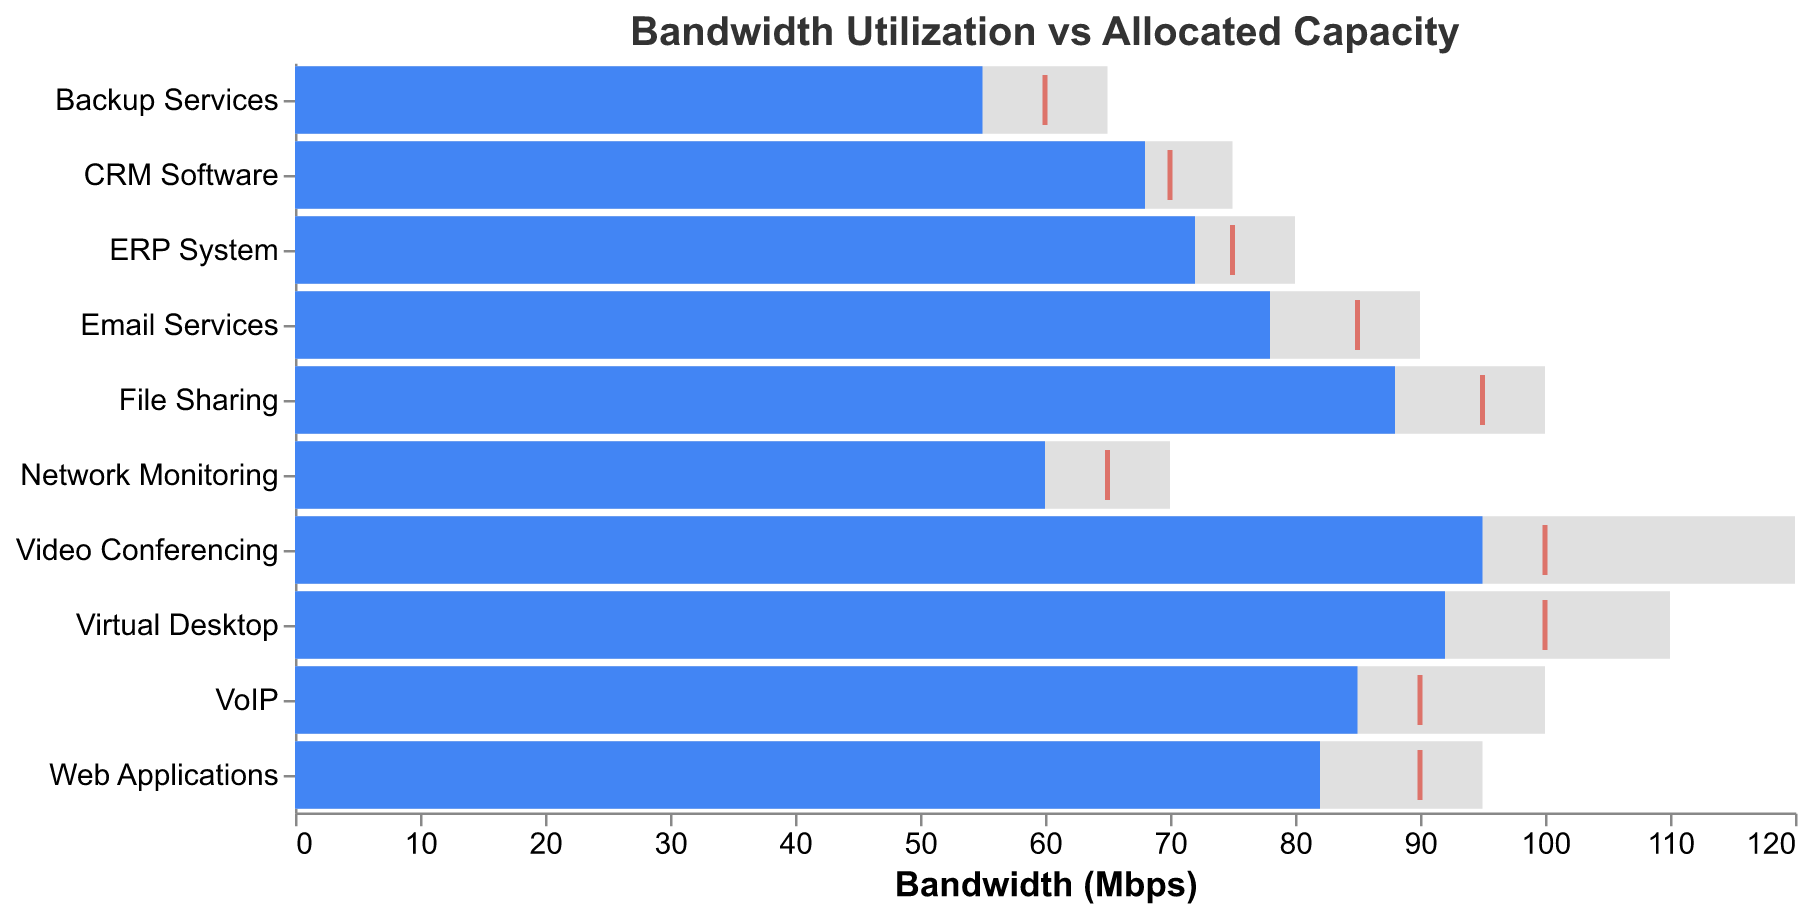What is the title of the chart? The title of the chart is displayed at the top and reads "Bandwidth Utilization vs Allocated Capacity".
Answer: Bandwidth Utilization vs Allocated Capacity What is the color of the bars representing actual usage? The color of the bars representing actual usage is blue, which can be observed from the blue bars on the chart.
Answer: Blue Which application has the highest actual usage? By looking at the lengths of the blue bars, "Video Conferencing" has the highest actual usage at 95 Mbps.
Answer: Video Conferencing How does the actual usage of 'VoIP' compare to its allocated capacity? For 'VoIP', the actual usage is 85 Mbps, and the allocated capacity is 100 Mbps. So, the actual usage is 15 Mbps less than the allocated capacity.
Answer: 15 Mbps less Which applications have actual usage meeting or exceeding their target? By comparing the blue bars to the red ticks, 'VoIP', 'Network Monitoring', 'Email Services', 'File Sharing', 'CRM Software', 'Backup Services', and 'Web Applications' meet or exceed their targets.
Answer: VoIP, Network Monitoring, Email Services, File Sharing, CRM Software, Backup Services, Web Applications What is the difference between the allocated capacity and the target for 'Email Services'? The allocated capacity for 'Email Services' is 90 Mbps, and the target is 85 Mbps. Therefore, the difference is 90 - 85 = 5 Mbps.
Answer: 5 Mbps What is the average actual usage of 'CRM Software' and 'Backup Services'? The actual usage for 'CRM Software' is 68 Mbps and for 'Backup Services' is 55 Mbps. The average is (68 + 55) / 2 = 61.5 Mbps.
Answer: 61.5 Mbps Which application has the smallest difference between actual usage and its target? By examining the proximity of the blue bars to the red ticks, 'Network Monitoring' has the smallest difference with actual usage of 60 Mbps and a target of 65 Mbps, a 5 Mbps difference.
Answer: Network Monitoring For 'Virtual Desktop', how far is the actual usage from its allocated capacity and target? The actual usage of 'Virtual Desktop' is 92 Mbps, the allocated capacity is 110 Mbps, and the target is 100 Mbps. Difference from allocated capacity: 110 - 92 = 18 Mbps. Difference from target: 100 - 92 = 8 Mbps.
Answer: 18 Mbps from allocated capacity, 8 Mbps from target Which application is closest to its allocated capacity? By comparing the length of the blue bars to the gray bars, 'File Sharing' comes closest to its allocated capacity, with an actual usage of 88 Mbps and allocated capacity of 100 Mbps.
Answer: File Sharing 